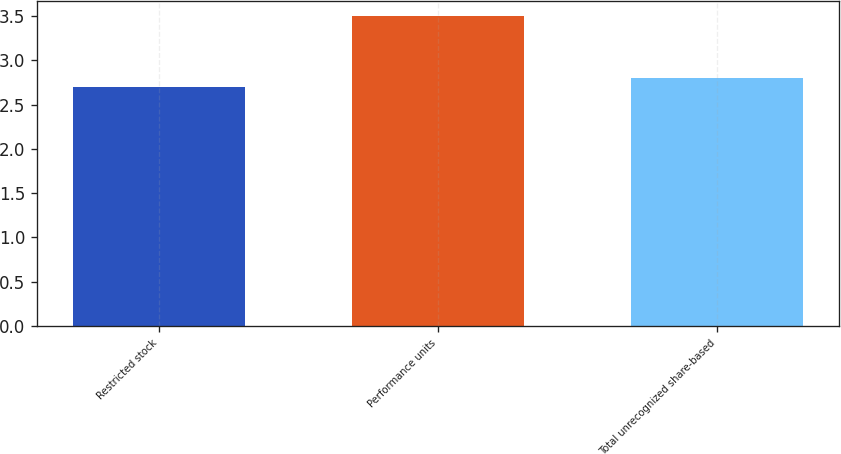Convert chart. <chart><loc_0><loc_0><loc_500><loc_500><bar_chart><fcel>Restricted stock<fcel>Performance units<fcel>Total unrecognized share-based<nl><fcel>2.7<fcel>3.5<fcel>2.8<nl></chart> 